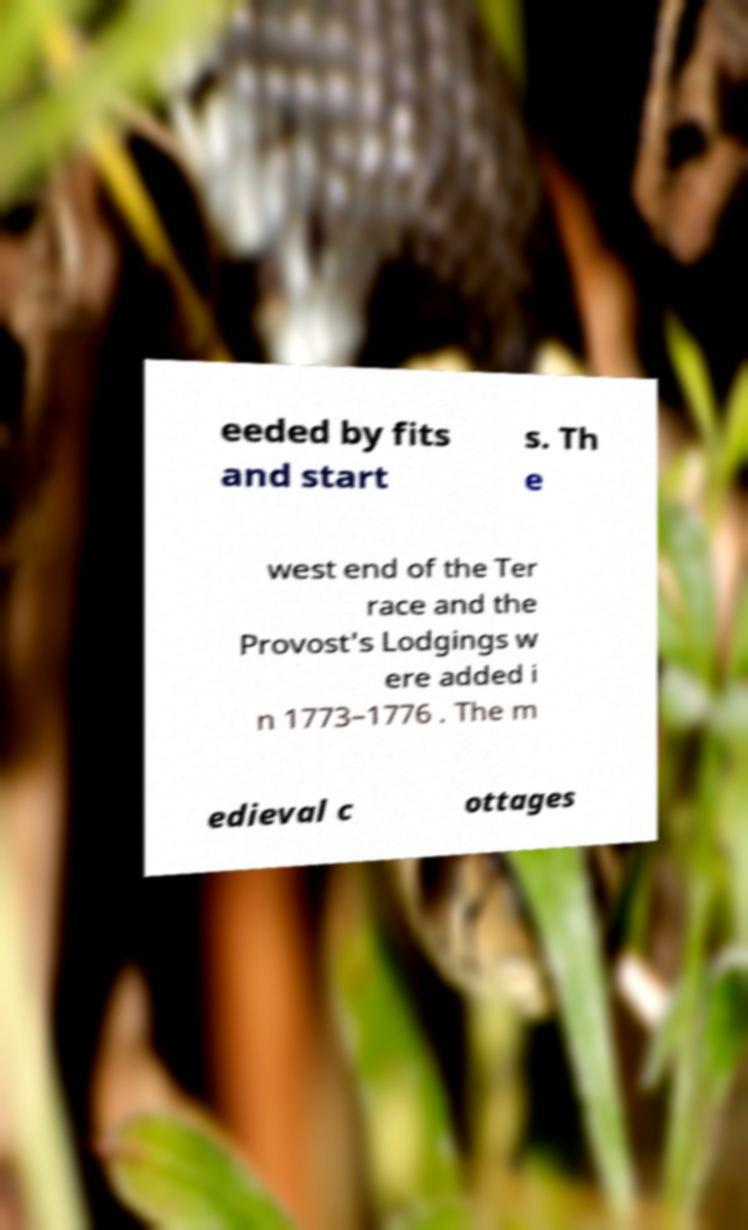Please read and relay the text visible in this image. What does it say? eeded by fits and start s. Th e west end of the Ter race and the Provost's Lodgings w ere added i n 1773–1776 . The m edieval c ottages 